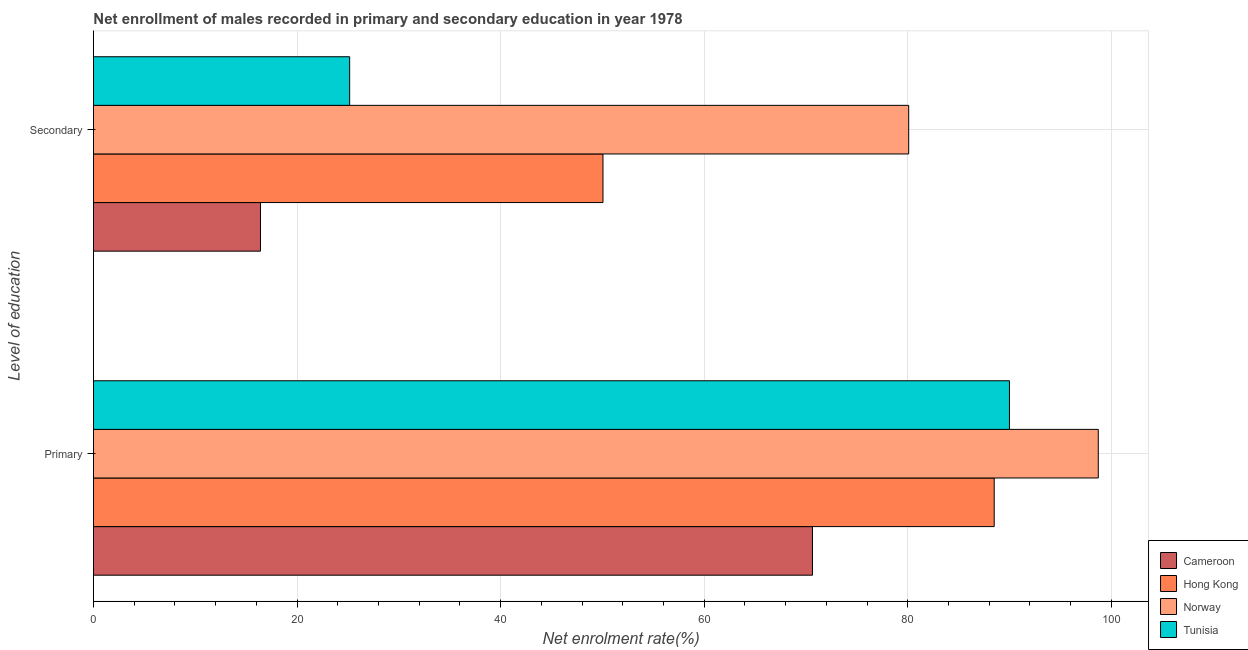How many different coloured bars are there?
Offer a very short reply. 4. How many groups of bars are there?
Your response must be concise. 2. How many bars are there on the 2nd tick from the top?
Offer a very short reply. 4. How many bars are there on the 2nd tick from the bottom?
Your answer should be compact. 4. What is the label of the 1st group of bars from the top?
Keep it short and to the point. Secondary. What is the enrollment rate in primary education in Hong Kong?
Provide a short and direct response. 88.5. Across all countries, what is the maximum enrollment rate in primary education?
Offer a very short reply. 98.72. Across all countries, what is the minimum enrollment rate in primary education?
Offer a very short reply. 70.64. In which country was the enrollment rate in primary education maximum?
Your answer should be very brief. Norway. In which country was the enrollment rate in primary education minimum?
Ensure brevity in your answer.  Cameroon. What is the total enrollment rate in secondary education in the graph?
Your response must be concise. 171.73. What is the difference between the enrollment rate in primary education in Cameroon and that in Norway?
Offer a terse response. -28.08. What is the difference between the enrollment rate in secondary education in Norway and the enrollment rate in primary education in Tunisia?
Provide a succinct answer. -9.9. What is the average enrollment rate in secondary education per country?
Ensure brevity in your answer.  42.93. What is the difference between the enrollment rate in primary education and enrollment rate in secondary education in Hong Kong?
Keep it short and to the point. 38.44. In how many countries, is the enrollment rate in primary education greater than 56 %?
Give a very brief answer. 4. What is the ratio of the enrollment rate in primary education in Cameroon to that in Norway?
Offer a very short reply. 0.72. What does the 4th bar from the top in Secondary represents?
Provide a succinct answer. Cameroon. What does the 4th bar from the bottom in Primary represents?
Provide a short and direct response. Tunisia. How many bars are there?
Your answer should be very brief. 8. What is the difference between two consecutive major ticks on the X-axis?
Provide a short and direct response. 20. Are the values on the major ticks of X-axis written in scientific E-notation?
Provide a succinct answer. No. Does the graph contain grids?
Ensure brevity in your answer.  Yes. Where does the legend appear in the graph?
Provide a short and direct response. Bottom right. How many legend labels are there?
Keep it short and to the point. 4. How are the legend labels stacked?
Your response must be concise. Vertical. What is the title of the graph?
Offer a very short reply. Net enrollment of males recorded in primary and secondary education in year 1978. Does "Sao Tome and Principe" appear as one of the legend labels in the graph?
Offer a very short reply. No. What is the label or title of the X-axis?
Give a very brief answer. Net enrolment rate(%). What is the label or title of the Y-axis?
Provide a short and direct response. Level of education. What is the Net enrolment rate(%) in Cameroon in Primary?
Give a very brief answer. 70.64. What is the Net enrolment rate(%) in Hong Kong in Primary?
Provide a succinct answer. 88.5. What is the Net enrolment rate(%) in Norway in Primary?
Your answer should be compact. 98.72. What is the Net enrolment rate(%) in Tunisia in Primary?
Offer a very short reply. 89.99. What is the Net enrolment rate(%) of Cameroon in Secondary?
Give a very brief answer. 16.41. What is the Net enrolment rate(%) of Hong Kong in Secondary?
Provide a succinct answer. 50.06. What is the Net enrolment rate(%) in Norway in Secondary?
Your answer should be compact. 80.09. What is the Net enrolment rate(%) in Tunisia in Secondary?
Give a very brief answer. 25.17. Across all Level of education, what is the maximum Net enrolment rate(%) of Cameroon?
Offer a terse response. 70.64. Across all Level of education, what is the maximum Net enrolment rate(%) in Hong Kong?
Provide a succinct answer. 88.5. Across all Level of education, what is the maximum Net enrolment rate(%) in Norway?
Give a very brief answer. 98.72. Across all Level of education, what is the maximum Net enrolment rate(%) of Tunisia?
Keep it short and to the point. 89.99. Across all Level of education, what is the minimum Net enrolment rate(%) of Cameroon?
Offer a terse response. 16.41. Across all Level of education, what is the minimum Net enrolment rate(%) in Hong Kong?
Provide a succinct answer. 50.06. Across all Level of education, what is the minimum Net enrolment rate(%) in Norway?
Your answer should be compact. 80.09. Across all Level of education, what is the minimum Net enrolment rate(%) in Tunisia?
Offer a terse response. 25.17. What is the total Net enrolment rate(%) of Cameroon in the graph?
Your answer should be compact. 87.05. What is the total Net enrolment rate(%) of Hong Kong in the graph?
Ensure brevity in your answer.  138.55. What is the total Net enrolment rate(%) of Norway in the graph?
Your answer should be compact. 178.81. What is the total Net enrolment rate(%) in Tunisia in the graph?
Keep it short and to the point. 115.16. What is the difference between the Net enrolment rate(%) of Cameroon in Primary and that in Secondary?
Offer a very short reply. 54.23. What is the difference between the Net enrolment rate(%) in Hong Kong in Primary and that in Secondary?
Your answer should be very brief. 38.44. What is the difference between the Net enrolment rate(%) in Norway in Primary and that in Secondary?
Provide a succinct answer. 18.63. What is the difference between the Net enrolment rate(%) of Tunisia in Primary and that in Secondary?
Your answer should be compact. 64.82. What is the difference between the Net enrolment rate(%) in Cameroon in Primary and the Net enrolment rate(%) in Hong Kong in Secondary?
Provide a short and direct response. 20.58. What is the difference between the Net enrolment rate(%) of Cameroon in Primary and the Net enrolment rate(%) of Norway in Secondary?
Provide a short and direct response. -9.45. What is the difference between the Net enrolment rate(%) of Cameroon in Primary and the Net enrolment rate(%) of Tunisia in Secondary?
Ensure brevity in your answer.  45.47. What is the difference between the Net enrolment rate(%) of Hong Kong in Primary and the Net enrolment rate(%) of Norway in Secondary?
Give a very brief answer. 8.4. What is the difference between the Net enrolment rate(%) of Hong Kong in Primary and the Net enrolment rate(%) of Tunisia in Secondary?
Offer a terse response. 63.32. What is the difference between the Net enrolment rate(%) of Norway in Primary and the Net enrolment rate(%) of Tunisia in Secondary?
Offer a terse response. 73.55. What is the average Net enrolment rate(%) of Cameroon per Level of education?
Your answer should be very brief. 43.52. What is the average Net enrolment rate(%) in Hong Kong per Level of education?
Keep it short and to the point. 69.28. What is the average Net enrolment rate(%) in Norway per Level of education?
Ensure brevity in your answer.  89.41. What is the average Net enrolment rate(%) in Tunisia per Level of education?
Your response must be concise. 57.58. What is the difference between the Net enrolment rate(%) of Cameroon and Net enrolment rate(%) of Hong Kong in Primary?
Ensure brevity in your answer.  -17.86. What is the difference between the Net enrolment rate(%) of Cameroon and Net enrolment rate(%) of Norway in Primary?
Make the answer very short. -28.08. What is the difference between the Net enrolment rate(%) in Cameroon and Net enrolment rate(%) in Tunisia in Primary?
Provide a short and direct response. -19.35. What is the difference between the Net enrolment rate(%) in Hong Kong and Net enrolment rate(%) in Norway in Primary?
Give a very brief answer. -10.23. What is the difference between the Net enrolment rate(%) in Hong Kong and Net enrolment rate(%) in Tunisia in Primary?
Provide a short and direct response. -1.5. What is the difference between the Net enrolment rate(%) of Norway and Net enrolment rate(%) of Tunisia in Primary?
Offer a terse response. 8.73. What is the difference between the Net enrolment rate(%) in Cameroon and Net enrolment rate(%) in Hong Kong in Secondary?
Keep it short and to the point. -33.65. What is the difference between the Net enrolment rate(%) in Cameroon and Net enrolment rate(%) in Norway in Secondary?
Give a very brief answer. -63.69. What is the difference between the Net enrolment rate(%) of Cameroon and Net enrolment rate(%) of Tunisia in Secondary?
Ensure brevity in your answer.  -8.76. What is the difference between the Net enrolment rate(%) of Hong Kong and Net enrolment rate(%) of Norway in Secondary?
Give a very brief answer. -30.03. What is the difference between the Net enrolment rate(%) of Hong Kong and Net enrolment rate(%) of Tunisia in Secondary?
Ensure brevity in your answer.  24.89. What is the difference between the Net enrolment rate(%) of Norway and Net enrolment rate(%) of Tunisia in Secondary?
Provide a short and direct response. 54.92. What is the ratio of the Net enrolment rate(%) of Cameroon in Primary to that in Secondary?
Ensure brevity in your answer.  4.31. What is the ratio of the Net enrolment rate(%) in Hong Kong in Primary to that in Secondary?
Your answer should be very brief. 1.77. What is the ratio of the Net enrolment rate(%) of Norway in Primary to that in Secondary?
Your answer should be very brief. 1.23. What is the ratio of the Net enrolment rate(%) in Tunisia in Primary to that in Secondary?
Offer a terse response. 3.58. What is the difference between the highest and the second highest Net enrolment rate(%) of Cameroon?
Offer a terse response. 54.23. What is the difference between the highest and the second highest Net enrolment rate(%) in Hong Kong?
Make the answer very short. 38.44. What is the difference between the highest and the second highest Net enrolment rate(%) of Norway?
Your answer should be compact. 18.63. What is the difference between the highest and the second highest Net enrolment rate(%) in Tunisia?
Your answer should be very brief. 64.82. What is the difference between the highest and the lowest Net enrolment rate(%) of Cameroon?
Provide a short and direct response. 54.23. What is the difference between the highest and the lowest Net enrolment rate(%) in Hong Kong?
Your answer should be very brief. 38.44. What is the difference between the highest and the lowest Net enrolment rate(%) of Norway?
Provide a short and direct response. 18.63. What is the difference between the highest and the lowest Net enrolment rate(%) of Tunisia?
Make the answer very short. 64.82. 